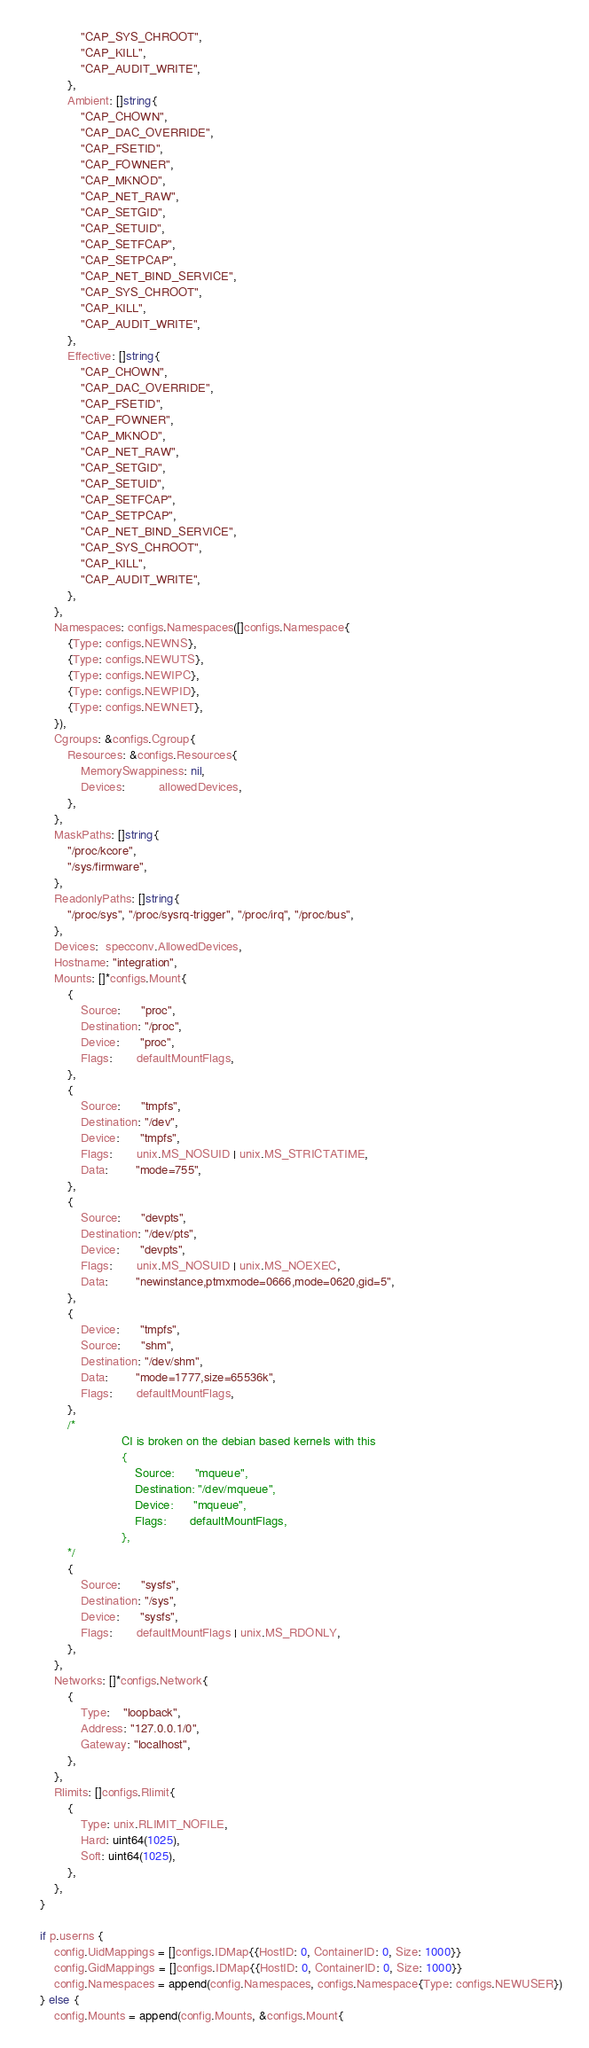<code> <loc_0><loc_0><loc_500><loc_500><_Go_>				"CAP_SYS_CHROOT",
				"CAP_KILL",
				"CAP_AUDIT_WRITE",
			},
			Ambient: []string{
				"CAP_CHOWN",
				"CAP_DAC_OVERRIDE",
				"CAP_FSETID",
				"CAP_FOWNER",
				"CAP_MKNOD",
				"CAP_NET_RAW",
				"CAP_SETGID",
				"CAP_SETUID",
				"CAP_SETFCAP",
				"CAP_SETPCAP",
				"CAP_NET_BIND_SERVICE",
				"CAP_SYS_CHROOT",
				"CAP_KILL",
				"CAP_AUDIT_WRITE",
			},
			Effective: []string{
				"CAP_CHOWN",
				"CAP_DAC_OVERRIDE",
				"CAP_FSETID",
				"CAP_FOWNER",
				"CAP_MKNOD",
				"CAP_NET_RAW",
				"CAP_SETGID",
				"CAP_SETUID",
				"CAP_SETFCAP",
				"CAP_SETPCAP",
				"CAP_NET_BIND_SERVICE",
				"CAP_SYS_CHROOT",
				"CAP_KILL",
				"CAP_AUDIT_WRITE",
			},
		},
		Namespaces: configs.Namespaces([]configs.Namespace{
			{Type: configs.NEWNS},
			{Type: configs.NEWUTS},
			{Type: configs.NEWIPC},
			{Type: configs.NEWPID},
			{Type: configs.NEWNET},
		}),
		Cgroups: &configs.Cgroup{
			Resources: &configs.Resources{
				MemorySwappiness: nil,
				Devices:          allowedDevices,
			},
		},
		MaskPaths: []string{
			"/proc/kcore",
			"/sys/firmware",
		},
		ReadonlyPaths: []string{
			"/proc/sys", "/proc/sysrq-trigger", "/proc/irq", "/proc/bus",
		},
		Devices:  specconv.AllowedDevices,
		Hostname: "integration",
		Mounts: []*configs.Mount{
			{
				Source:      "proc",
				Destination: "/proc",
				Device:      "proc",
				Flags:       defaultMountFlags,
			},
			{
				Source:      "tmpfs",
				Destination: "/dev",
				Device:      "tmpfs",
				Flags:       unix.MS_NOSUID | unix.MS_STRICTATIME,
				Data:        "mode=755",
			},
			{
				Source:      "devpts",
				Destination: "/dev/pts",
				Device:      "devpts",
				Flags:       unix.MS_NOSUID | unix.MS_NOEXEC,
				Data:        "newinstance,ptmxmode=0666,mode=0620,gid=5",
			},
			{
				Device:      "tmpfs",
				Source:      "shm",
				Destination: "/dev/shm",
				Data:        "mode=1777,size=65536k",
				Flags:       defaultMountFlags,
			},
			/*
				            CI is broken on the debian based kernels with this
							{
								Source:      "mqueue",
								Destination: "/dev/mqueue",
								Device:      "mqueue",
								Flags:       defaultMountFlags,
							},
			*/
			{
				Source:      "sysfs",
				Destination: "/sys",
				Device:      "sysfs",
				Flags:       defaultMountFlags | unix.MS_RDONLY,
			},
		},
		Networks: []*configs.Network{
			{
				Type:    "loopback",
				Address: "127.0.0.1/0",
				Gateway: "localhost",
			},
		},
		Rlimits: []configs.Rlimit{
			{
				Type: unix.RLIMIT_NOFILE,
				Hard: uint64(1025),
				Soft: uint64(1025),
			},
		},
	}

	if p.userns {
		config.UidMappings = []configs.IDMap{{HostID: 0, ContainerID: 0, Size: 1000}}
		config.GidMappings = []configs.IDMap{{HostID: 0, ContainerID: 0, Size: 1000}}
		config.Namespaces = append(config.Namespaces, configs.Namespace{Type: configs.NEWUSER})
	} else {
		config.Mounts = append(config.Mounts, &configs.Mount{</code> 